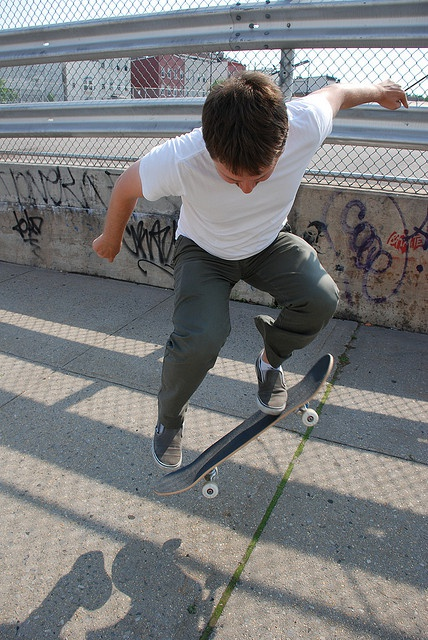Describe the objects in this image and their specific colors. I can see people in white, black, darkgray, gray, and lightgray tones and skateboard in white, gray, black, darkgray, and navy tones in this image. 